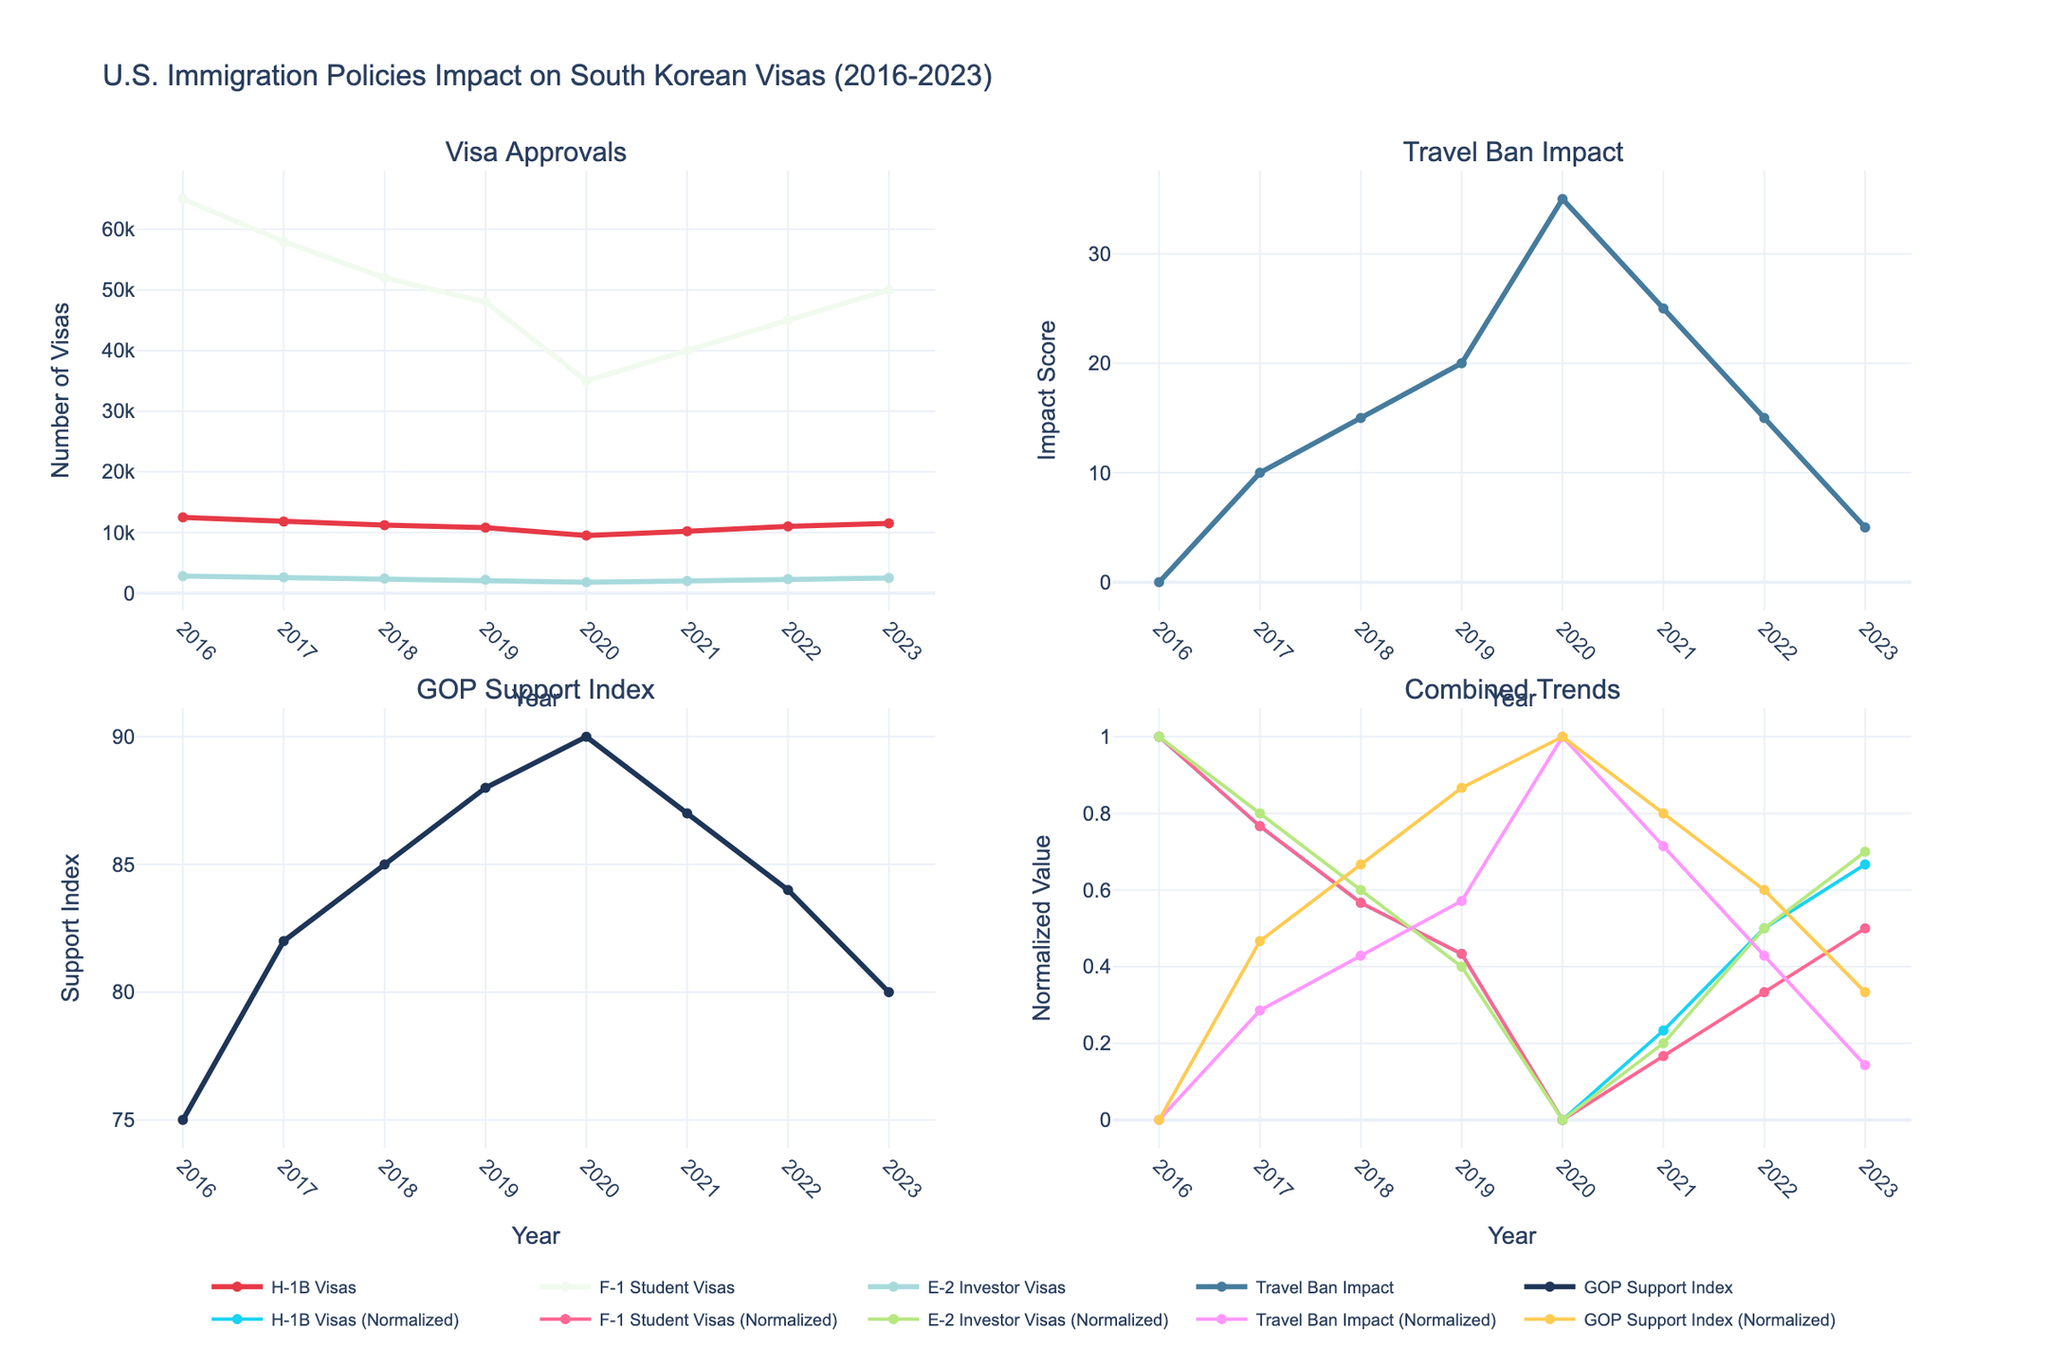What's the title of the figure? The title of the figure is located at the top center and reads "U.S. Immigration Policies Impact on South Korean Visas (2016-2023)."
Answer: U.S. Immigration Policies Impact on South Korean Visas (2016-2023) How many visa types are tracked in the Visa Approvals plot? In the Visa Approvals plot, there are three lines representing three distinct visa types: H-1B Visas, F-1 Student Visas, and E-2 Investor Visas.
Answer: Three What does the y-axis represent in the Travel Ban Impact plot? The y-axis in the Travel Ban Impact plot represents the "Impact Score" related to the travel ban.
Answer: Impact Score In which year did H-1B Visa approvals reach their lowest point? To find when the H-1B Visa approvals were the lowest, observe the H-1B Visa line in the Visa Approvals plot. The lowest point occurs in the year 2020, with 9,500 H-1B Visas approved.
Answer: 2020 Between 2016 and 2023, what is the general trend observed in the GOP Support Index plot? The GOP Support Index plot shows a general upward trend from 2016 to 2020, reaching a peak in 2020 before slightly declining in subsequent years.
Answer: Increasing until 2020, then slightly decreasing Compare F-1 Student Visa approvals of 2017 and 2021. How much did the approvals decrease over this period? Comparing the data points for F-1 Student Visa approvals in 2017 and 2021 shows a decrease from 58,000 in 2017 to 40,000 in 2021. The difference is 58,000 - 40,000 = 18,000 approvals.
Answer: 18,000 What is the overall trend of the E-2 Investor Visas from 2016 to 2023? To assess the trend of E-2 Investor Visas, observe the E-2 Investor Visas line in the Visa Approvals plot. The trend shows a general decrease until 2020, followed by a slight increase until 2023.
Answer: Decreasing, then increasing Which plot shows normalized values for combined trends, and what does 'normalized' mean in this context? The Combined Trends plot (bottom right) represents normalized values. Normalized means scaling the data to a common range (e.g., 0 to 1) to compare trends on the same scale.
Answer: Combined Trends plot, normalized means scaling data to a common range During which year did the Travel Ban Impact score peak, and what was the score? The Travel Ban Impact score peaked in the year 2020, reaching a score of 35 as shown in the Travel Ban Impact plot.
Answer: 2020, 35 When did F-1 Student Visa approvals start to recover after 2020? F-1 Student Visa approvals started to recover in 2021, as observed in the Visa Approvals plot where the line begins to rise from 2020 to 2021.
Answer: 2021 